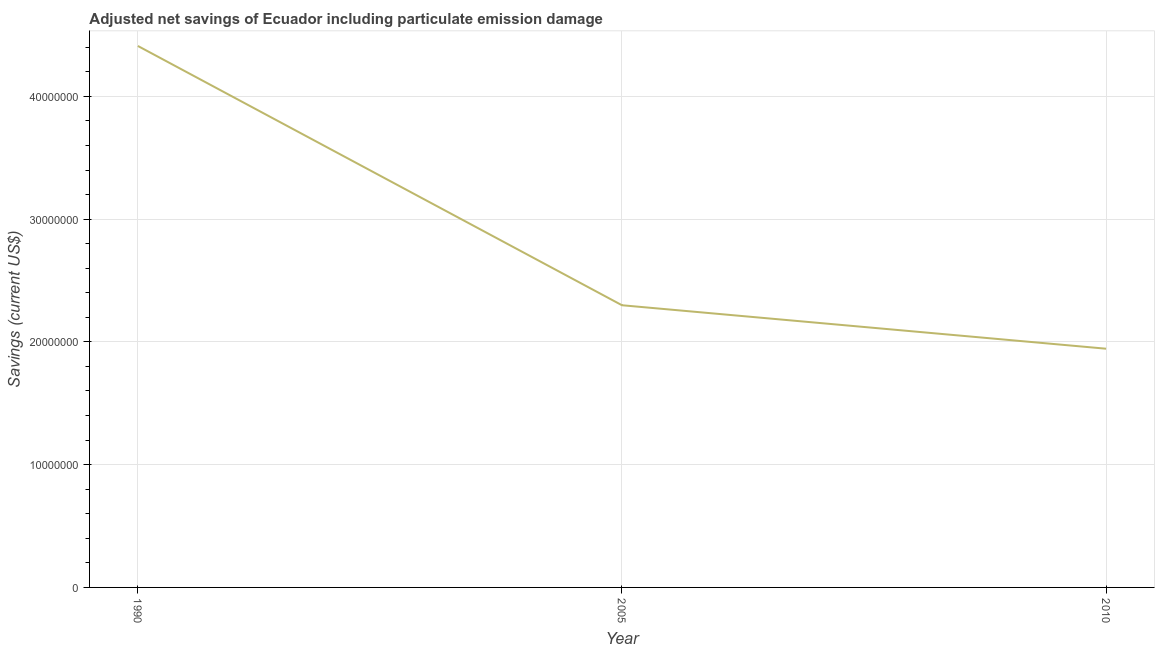What is the adjusted net savings in 1990?
Your answer should be compact. 4.41e+07. Across all years, what is the maximum adjusted net savings?
Offer a terse response. 4.41e+07. Across all years, what is the minimum adjusted net savings?
Keep it short and to the point. 1.94e+07. In which year was the adjusted net savings maximum?
Your answer should be compact. 1990. In which year was the adjusted net savings minimum?
Offer a terse response. 2010. What is the sum of the adjusted net savings?
Make the answer very short. 8.65e+07. What is the difference between the adjusted net savings in 1990 and 2010?
Your response must be concise. 2.47e+07. What is the average adjusted net savings per year?
Provide a succinct answer. 2.88e+07. What is the median adjusted net savings?
Your answer should be very brief. 2.30e+07. What is the ratio of the adjusted net savings in 2005 to that in 2010?
Give a very brief answer. 1.18. Is the adjusted net savings in 1990 less than that in 2010?
Offer a terse response. No. Is the difference between the adjusted net savings in 1990 and 2005 greater than the difference between any two years?
Make the answer very short. No. What is the difference between the highest and the second highest adjusted net savings?
Offer a terse response. 2.11e+07. What is the difference between the highest and the lowest adjusted net savings?
Make the answer very short. 2.47e+07. How many lines are there?
Make the answer very short. 1. Does the graph contain any zero values?
Ensure brevity in your answer.  No. What is the title of the graph?
Keep it short and to the point. Adjusted net savings of Ecuador including particulate emission damage. What is the label or title of the Y-axis?
Give a very brief answer. Savings (current US$). What is the Savings (current US$) of 1990?
Your response must be concise. 4.41e+07. What is the Savings (current US$) in 2005?
Your answer should be very brief. 2.30e+07. What is the Savings (current US$) in 2010?
Your answer should be very brief. 1.94e+07. What is the difference between the Savings (current US$) in 1990 and 2005?
Keep it short and to the point. 2.11e+07. What is the difference between the Savings (current US$) in 1990 and 2010?
Provide a succinct answer. 2.47e+07. What is the difference between the Savings (current US$) in 2005 and 2010?
Ensure brevity in your answer.  3.54e+06. What is the ratio of the Savings (current US$) in 1990 to that in 2005?
Provide a succinct answer. 1.92. What is the ratio of the Savings (current US$) in 1990 to that in 2010?
Provide a succinct answer. 2.27. What is the ratio of the Savings (current US$) in 2005 to that in 2010?
Your response must be concise. 1.18. 